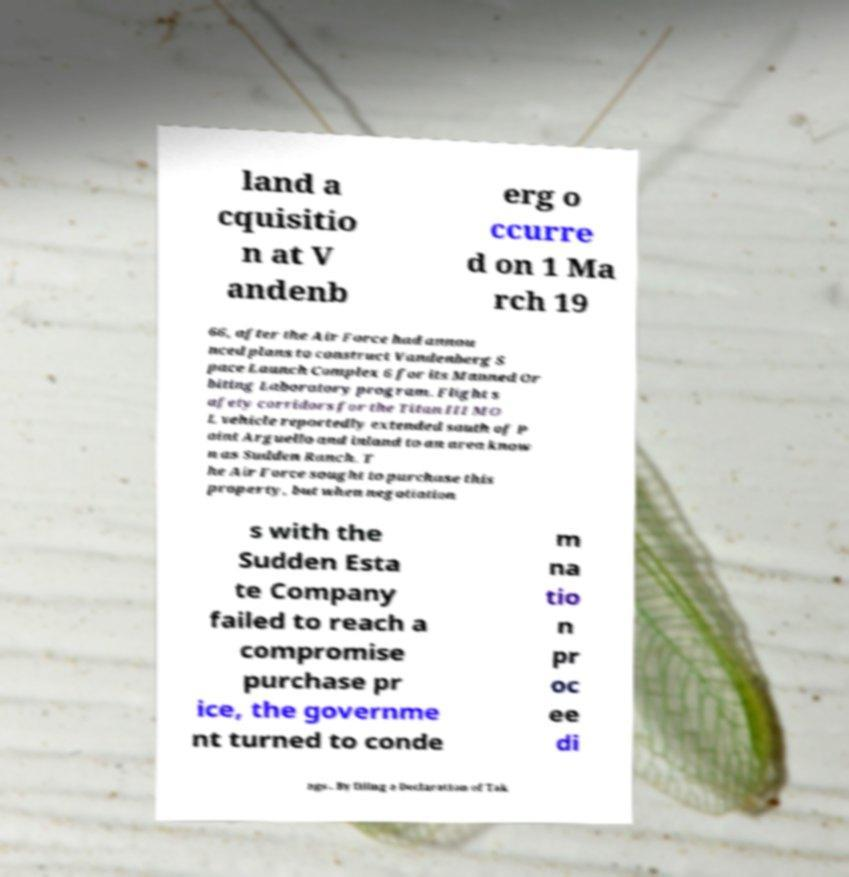Could you extract and type out the text from this image? land a cquisitio n at V andenb erg o ccurre d on 1 Ma rch 19 66, after the Air Force had annou nced plans to construct Vandenberg S pace Launch Complex 6 for its Manned Or biting Laboratory program. Flight s afety corridors for the Titan III MO L vehicle reportedly extended south of P oint Arguello and inland to an area know n as Sudden Ranch. T he Air Force sought to purchase this property, but when negotiation s with the Sudden Esta te Company failed to reach a compromise purchase pr ice, the governme nt turned to conde m na tio n pr oc ee di ngs . By filing a Declaration of Tak 